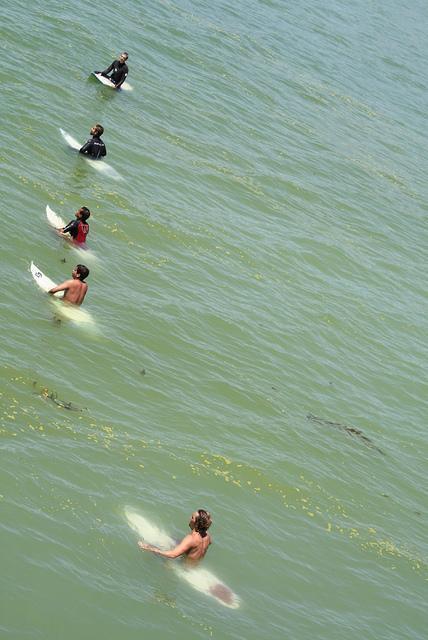How many surfboards are on the water?
Give a very brief answer. 5. How many horses are there?
Give a very brief answer. 0. 